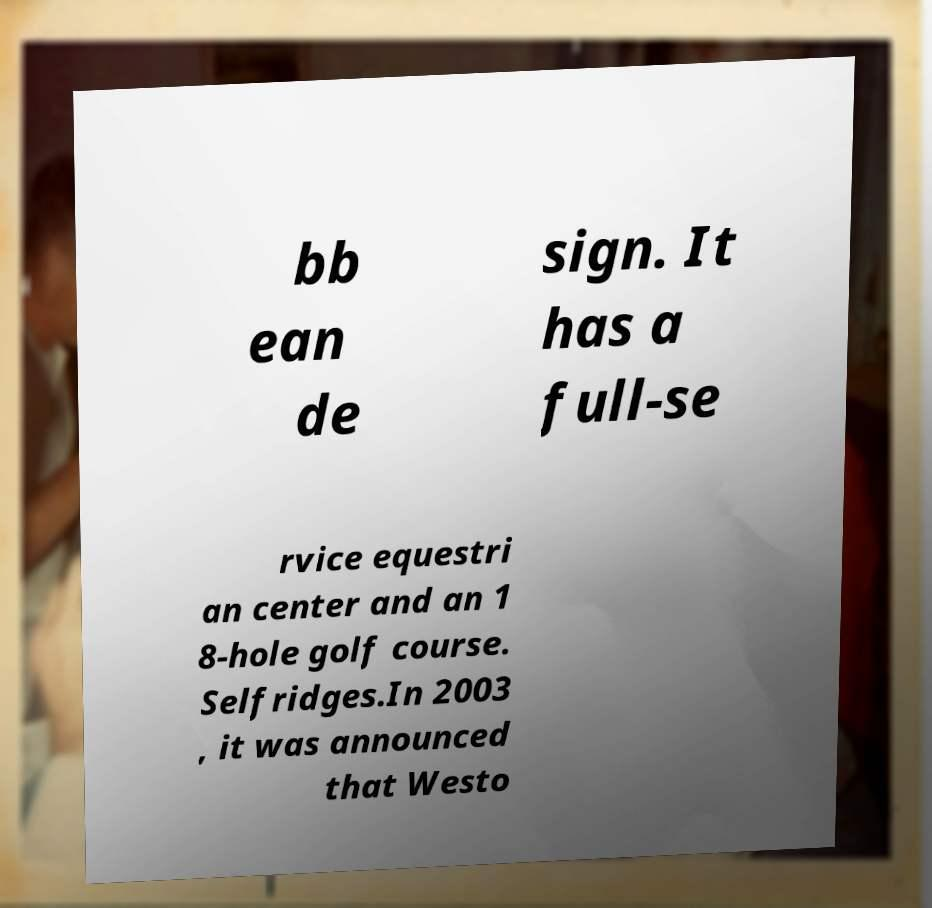There's text embedded in this image that I need extracted. Can you transcribe it verbatim? bb ean de sign. It has a full-se rvice equestri an center and an 1 8-hole golf course. Selfridges.In 2003 , it was announced that Westo 